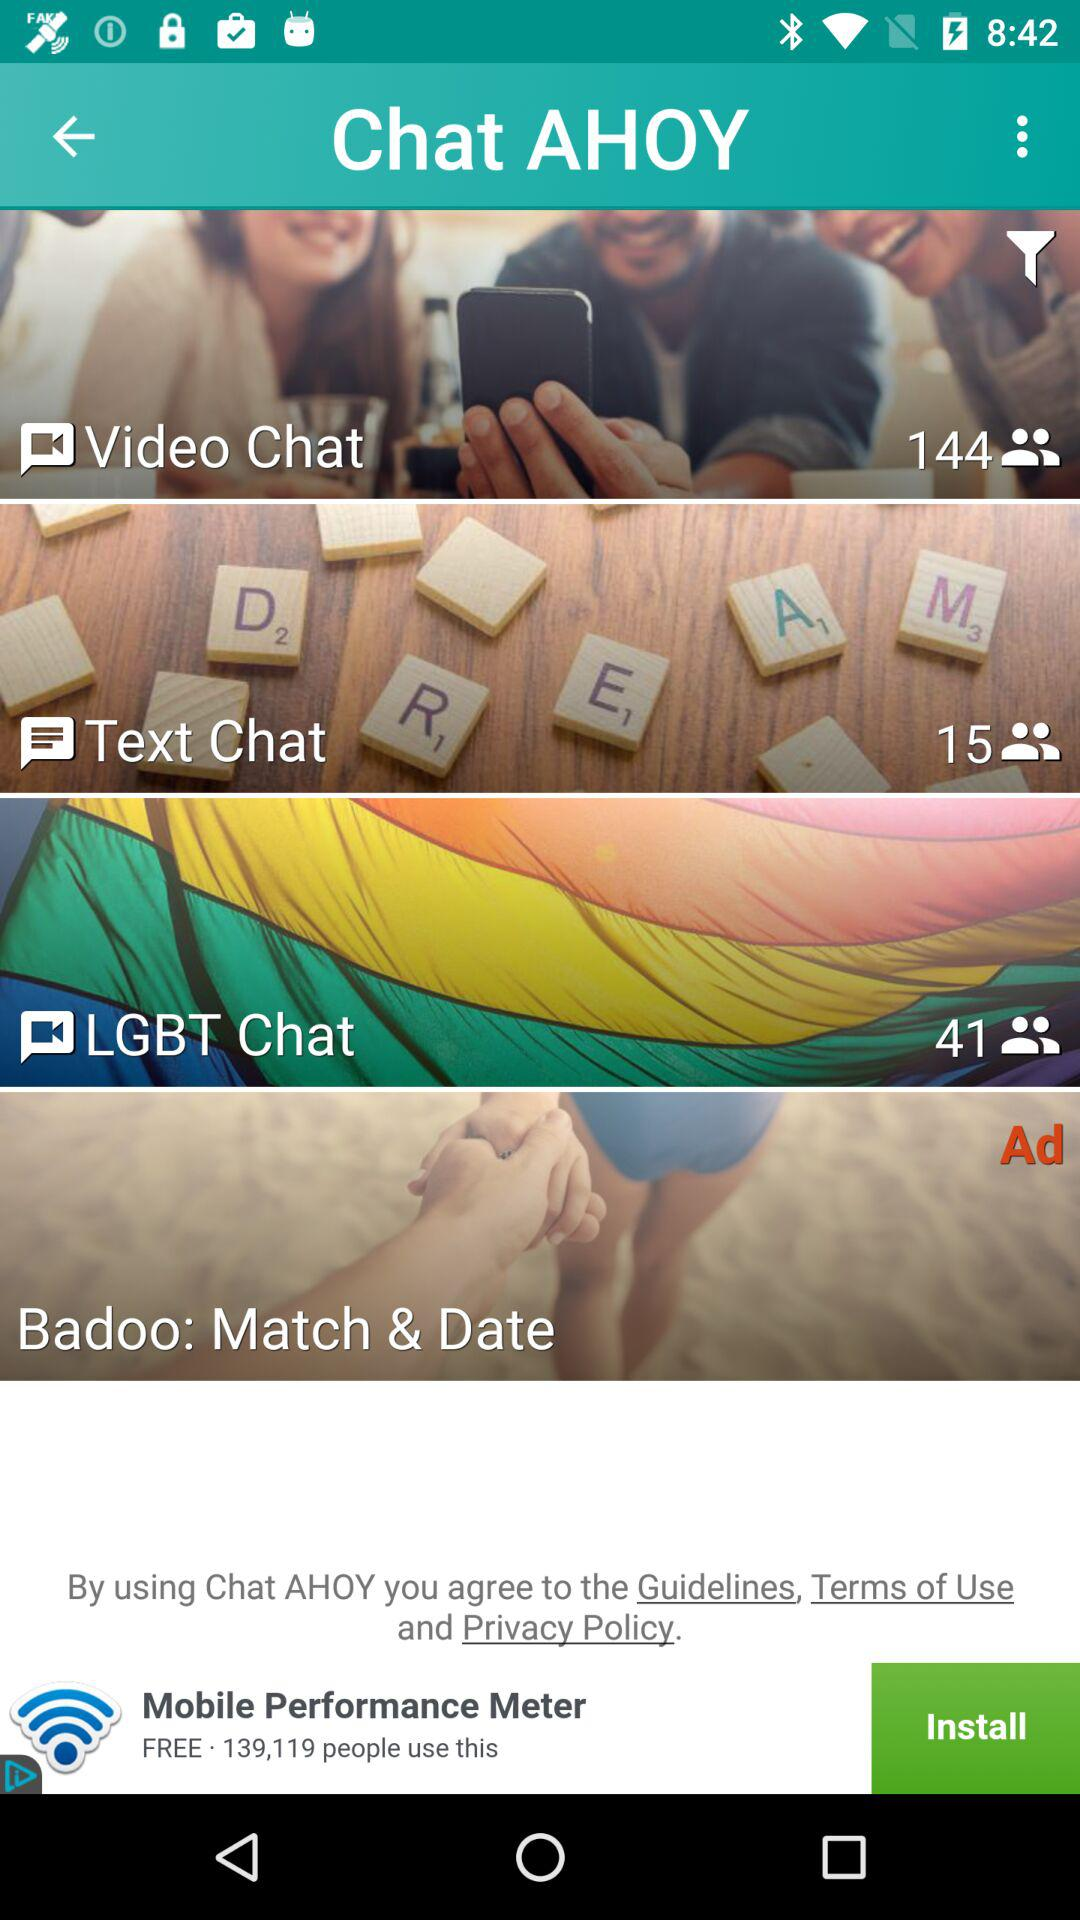How many users are in "Text Chat"? There are 15 users in "Text Chat". 